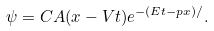Convert formula to latex. <formula><loc_0><loc_0><loc_500><loc_500>\psi = C A ( x - V t ) e ^ { - ( E t - p x ) / } .</formula> 